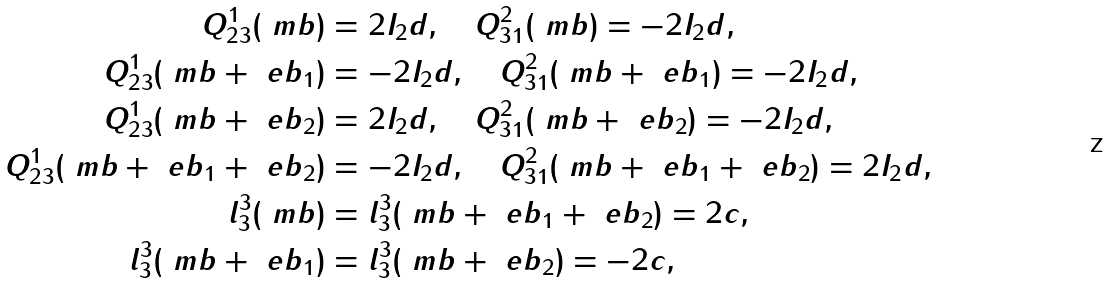Convert formula to latex. <formula><loc_0><loc_0><loc_500><loc_500>Q ^ { 1 } _ { 2 3 } ( \ m b ) & = 2 I _ { 2 } d , \quad Q ^ { 2 } _ { 3 1 } ( \ m b ) = - 2 I _ { 2 } d , \\ Q ^ { 1 } _ { 2 3 } ( \ m b + \ e b _ { 1 } ) & = - 2 I _ { 2 } d , \quad Q ^ { 2 } _ { 3 1 } ( \ m b + \ e b _ { 1 } ) = - 2 I _ { 2 } d , \\ Q ^ { 1 } _ { 2 3 } ( \ m b + \ e b _ { 2 } ) & = 2 I _ { 2 } d , \quad Q ^ { 2 } _ { 3 1 } ( \ m b + \ e b _ { 2 } ) = - 2 I _ { 2 } d , \\ Q ^ { 1 } _ { 2 3 } ( \ m b + \ e b _ { 1 } + \ e b _ { 2 } ) & = - 2 I _ { 2 } d , \quad Q ^ { 2 } _ { 3 1 } ( \ m b + \ e b _ { 1 } + \ e b _ { 2 } ) = 2 I _ { 2 } d , \\ l _ { 3 } ^ { 3 } ( \ m b ) & = l ^ { 3 } _ { 3 } ( \ m b + \ e b _ { 1 } + \ e b _ { 2 } ) = 2 c , \\ l _ { 3 } ^ { 3 } ( \ m b + \ e b _ { 1 } ) & = l ^ { 3 } _ { 3 } ( \ m b + \ e b _ { 2 } ) = - 2 c ,</formula> 